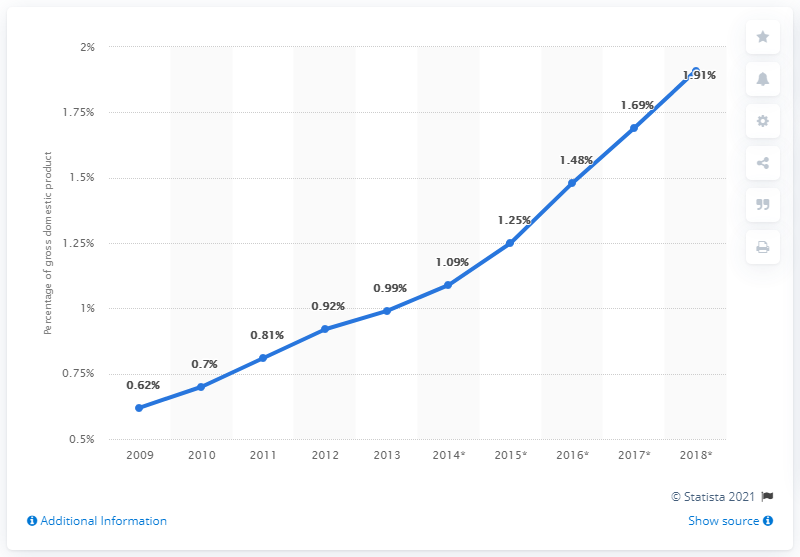Specify some key components in this picture. In 2013, B2C e-commerce accounted for 0.99% of the total GDP of Western Europe. 